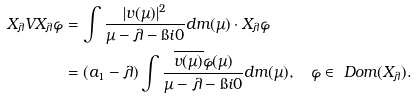<formula> <loc_0><loc_0><loc_500><loc_500>X _ { \lambda } V X _ { \lambda } \varphi & = \int \frac { | v ( \mu ) | ^ { 2 } } { \mu - \lambda - \i i 0 } d m ( \mu ) \cdot X _ { \lambda } \varphi \\ & = ( a _ { 1 } - \lambda ) \int \frac { \overline { v ( \mu ) } \varphi ( \mu ) } { \mu - \lambda - \i i 0 } d m ( \mu ) , \quad \varphi \in \ D o m ( X _ { \lambda } ) .</formula> 